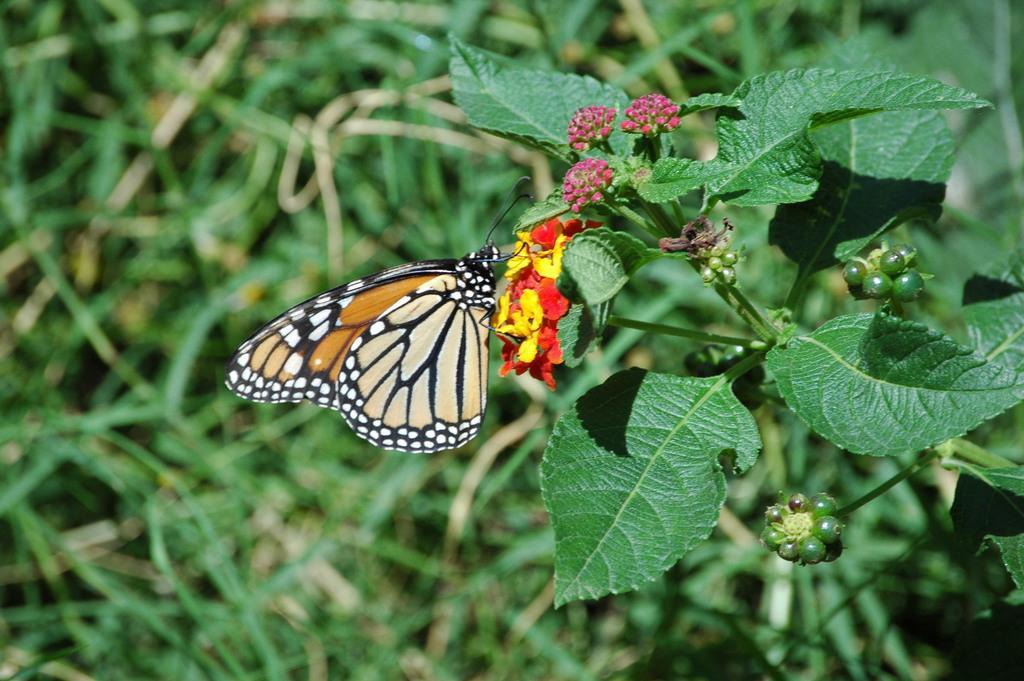Can you describe this image briefly? Here we can see leaves and butterfly is on flowers. Background it is blur. 